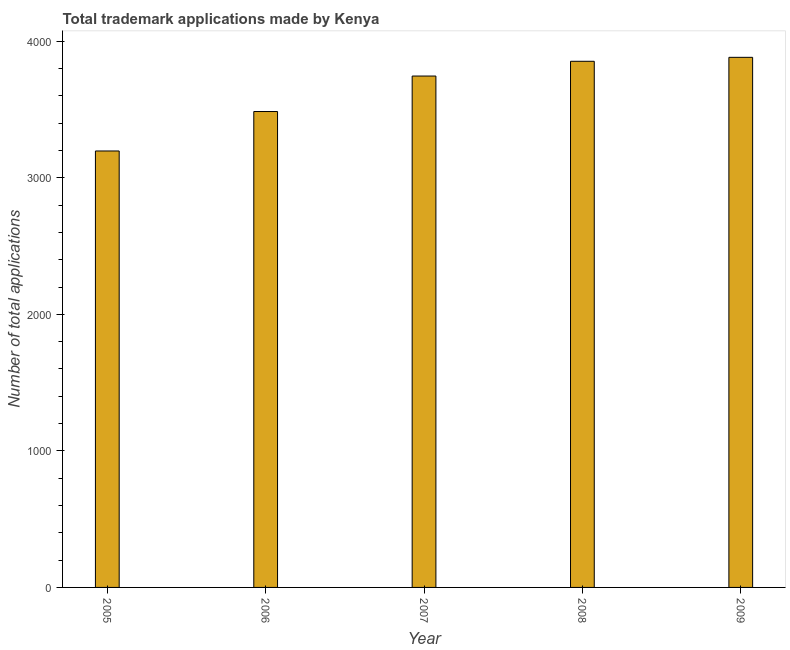Does the graph contain any zero values?
Make the answer very short. No. Does the graph contain grids?
Your answer should be compact. No. What is the title of the graph?
Provide a short and direct response. Total trademark applications made by Kenya. What is the label or title of the Y-axis?
Offer a very short reply. Number of total applications. What is the number of trademark applications in 2008?
Give a very brief answer. 3854. Across all years, what is the maximum number of trademark applications?
Offer a terse response. 3883. Across all years, what is the minimum number of trademark applications?
Provide a succinct answer. 3197. What is the sum of the number of trademark applications?
Offer a very short reply. 1.82e+04. What is the difference between the number of trademark applications in 2008 and 2009?
Your answer should be compact. -29. What is the average number of trademark applications per year?
Keep it short and to the point. 3633. What is the median number of trademark applications?
Provide a succinct answer. 3746. What is the ratio of the number of trademark applications in 2006 to that in 2008?
Your answer should be compact. 0.91. Is the number of trademark applications in 2005 less than that in 2006?
Your response must be concise. Yes. Is the difference between the number of trademark applications in 2005 and 2009 greater than the difference between any two years?
Give a very brief answer. Yes. Is the sum of the number of trademark applications in 2006 and 2007 greater than the maximum number of trademark applications across all years?
Provide a short and direct response. Yes. What is the difference between the highest and the lowest number of trademark applications?
Offer a terse response. 686. In how many years, is the number of trademark applications greater than the average number of trademark applications taken over all years?
Your response must be concise. 3. How many bars are there?
Offer a very short reply. 5. Are all the bars in the graph horizontal?
Make the answer very short. No. What is the Number of total applications of 2005?
Offer a very short reply. 3197. What is the Number of total applications of 2006?
Ensure brevity in your answer.  3486. What is the Number of total applications in 2007?
Your answer should be compact. 3746. What is the Number of total applications of 2008?
Give a very brief answer. 3854. What is the Number of total applications of 2009?
Ensure brevity in your answer.  3883. What is the difference between the Number of total applications in 2005 and 2006?
Your answer should be very brief. -289. What is the difference between the Number of total applications in 2005 and 2007?
Provide a short and direct response. -549. What is the difference between the Number of total applications in 2005 and 2008?
Ensure brevity in your answer.  -657. What is the difference between the Number of total applications in 2005 and 2009?
Give a very brief answer. -686. What is the difference between the Number of total applications in 2006 and 2007?
Ensure brevity in your answer.  -260. What is the difference between the Number of total applications in 2006 and 2008?
Ensure brevity in your answer.  -368. What is the difference between the Number of total applications in 2006 and 2009?
Make the answer very short. -397. What is the difference between the Number of total applications in 2007 and 2008?
Your answer should be very brief. -108. What is the difference between the Number of total applications in 2007 and 2009?
Offer a terse response. -137. What is the difference between the Number of total applications in 2008 and 2009?
Provide a succinct answer. -29. What is the ratio of the Number of total applications in 2005 to that in 2006?
Your answer should be very brief. 0.92. What is the ratio of the Number of total applications in 2005 to that in 2007?
Make the answer very short. 0.85. What is the ratio of the Number of total applications in 2005 to that in 2008?
Your response must be concise. 0.83. What is the ratio of the Number of total applications in 2005 to that in 2009?
Offer a terse response. 0.82. What is the ratio of the Number of total applications in 2006 to that in 2007?
Your response must be concise. 0.93. What is the ratio of the Number of total applications in 2006 to that in 2008?
Your answer should be very brief. 0.91. What is the ratio of the Number of total applications in 2006 to that in 2009?
Offer a very short reply. 0.9. 